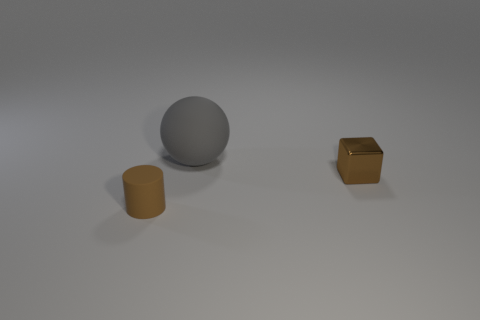Add 2 gray balls. How many objects exist? 5 Subtract all cylinders. How many objects are left? 2 Add 1 tiny brown things. How many tiny brown things exist? 3 Subtract 0 blue blocks. How many objects are left? 3 Subtract all gray matte spheres. Subtract all cylinders. How many objects are left? 1 Add 1 small matte cylinders. How many small matte cylinders are left? 2 